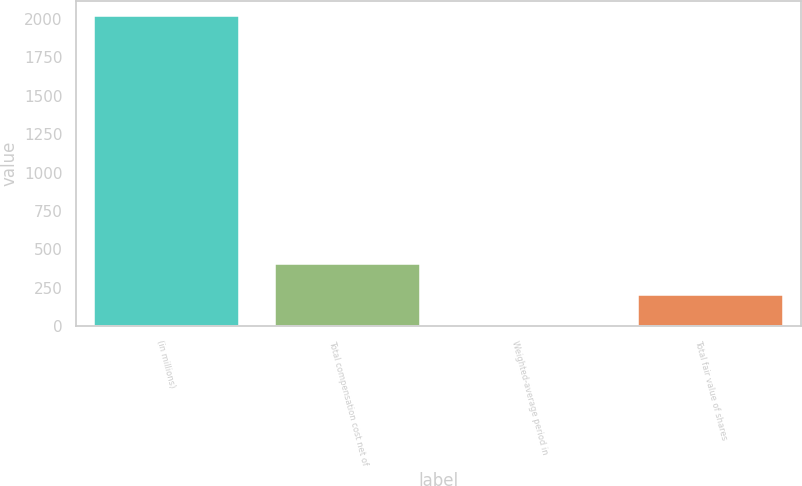Convert chart to OTSL. <chart><loc_0><loc_0><loc_500><loc_500><bar_chart><fcel>(in millions)<fcel>Total compensation cost net of<fcel>Weighted-average period in<fcel>Total fair value of shares<nl><fcel>2018<fcel>405.2<fcel>2<fcel>203.6<nl></chart> 